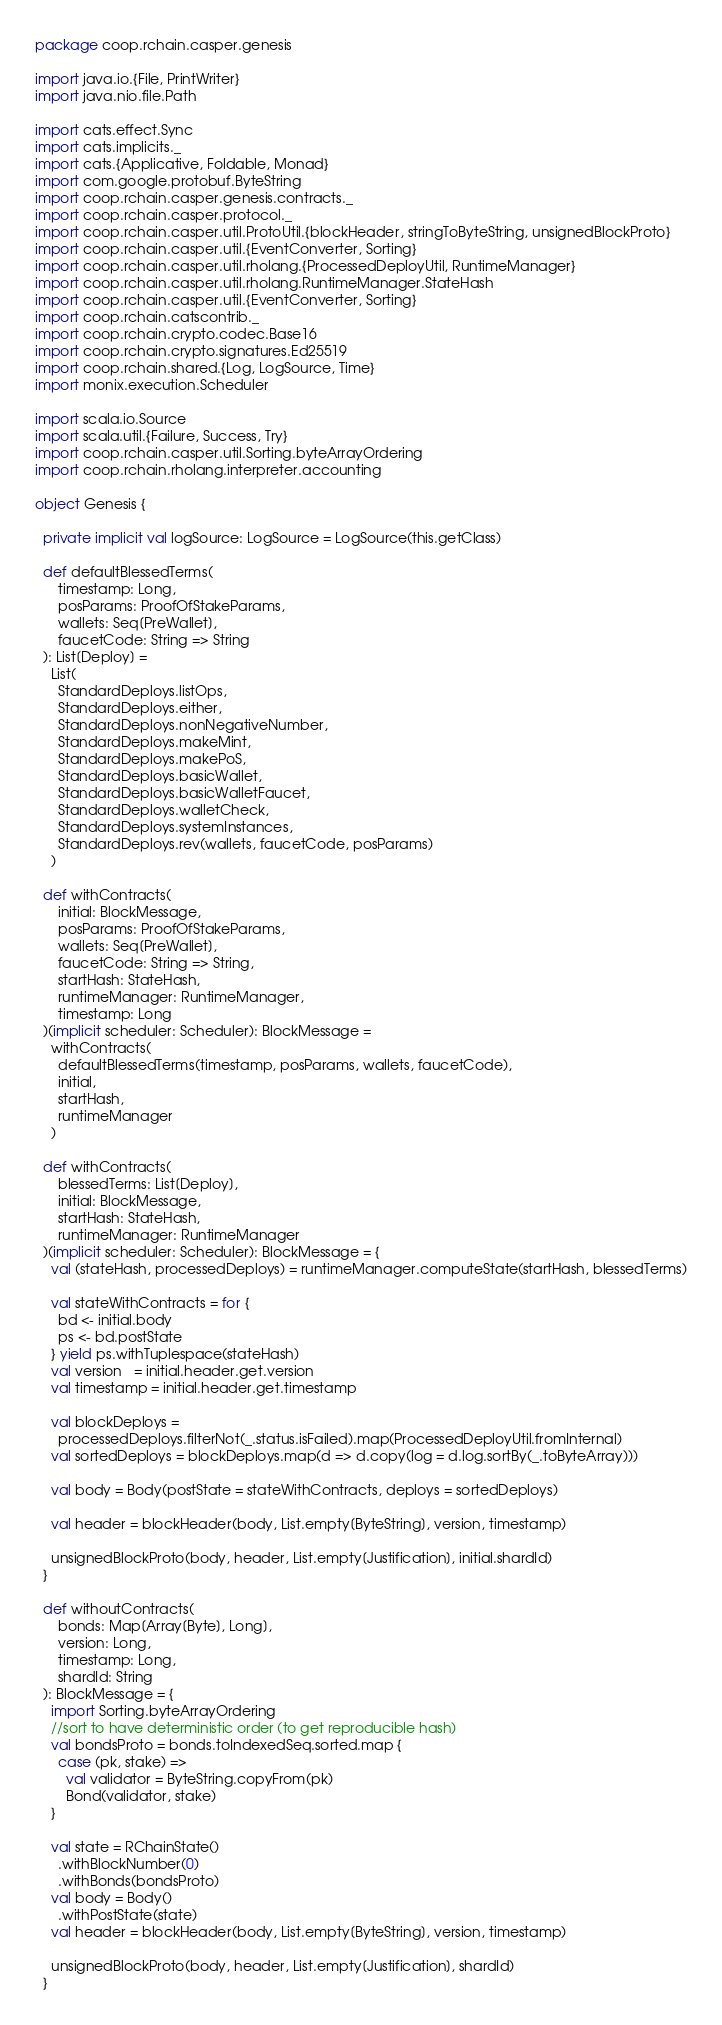<code> <loc_0><loc_0><loc_500><loc_500><_Scala_>package coop.rchain.casper.genesis

import java.io.{File, PrintWriter}
import java.nio.file.Path

import cats.effect.Sync
import cats.implicits._
import cats.{Applicative, Foldable, Monad}
import com.google.protobuf.ByteString
import coop.rchain.casper.genesis.contracts._
import coop.rchain.casper.protocol._
import coop.rchain.casper.util.ProtoUtil.{blockHeader, stringToByteString, unsignedBlockProto}
import coop.rchain.casper.util.{EventConverter, Sorting}
import coop.rchain.casper.util.rholang.{ProcessedDeployUtil, RuntimeManager}
import coop.rchain.casper.util.rholang.RuntimeManager.StateHash
import coop.rchain.casper.util.{EventConverter, Sorting}
import coop.rchain.catscontrib._
import coop.rchain.crypto.codec.Base16
import coop.rchain.crypto.signatures.Ed25519
import coop.rchain.shared.{Log, LogSource, Time}
import monix.execution.Scheduler

import scala.io.Source
import scala.util.{Failure, Success, Try}
import coop.rchain.casper.util.Sorting.byteArrayOrdering
import coop.rchain.rholang.interpreter.accounting

object Genesis {

  private implicit val logSource: LogSource = LogSource(this.getClass)

  def defaultBlessedTerms(
      timestamp: Long,
      posParams: ProofOfStakeParams,
      wallets: Seq[PreWallet],
      faucetCode: String => String
  ): List[Deploy] =
    List(
      StandardDeploys.listOps,
      StandardDeploys.either,
      StandardDeploys.nonNegativeNumber,
      StandardDeploys.makeMint,
      StandardDeploys.makePoS,
      StandardDeploys.basicWallet,
      StandardDeploys.basicWalletFaucet,
      StandardDeploys.walletCheck,
      StandardDeploys.systemInstances,
      StandardDeploys.rev(wallets, faucetCode, posParams)
    )

  def withContracts(
      initial: BlockMessage,
      posParams: ProofOfStakeParams,
      wallets: Seq[PreWallet],
      faucetCode: String => String,
      startHash: StateHash,
      runtimeManager: RuntimeManager,
      timestamp: Long
  )(implicit scheduler: Scheduler): BlockMessage =
    withContracts(
      defaultBlessedTerms(timestamp, posParams, wallets, faucetCode),
      initial,
      startHash,
      runtimeManager
    )

  def withContracts(
      blessedTerms: List[Deploy],
      initial: BlockMessage,
      startHash: StateHash,
      runtimeManager: RuntimeManager
  )(implicit scheduler: Scheduler): BlockMessage = {
    val (stateHash, processedDeploys) = runtimeManager.computeState(startHash, blessedTerms)

    val stateWithContracts = for {
      bd <- initial.body
      ps <- bd.postState
    } yield ps.withTuplespace(stateHash)
    val version   = initial.header.get.version
    val timestamp = initial.header.get.timestamp

    val blockDeploys =
      processedDeploys.filterNot(_.status.isFailed).map(ProcessedDeployUtil.fromInternal)
    val sortedDeploys = blockDeploys.map(d => d.copy(log = d.log.sortBy(_.toByteArray)))

    val body = Body(postState = stateWithContracts, deploys = sortedDeploys)

    val header = blockHeader(body, List.empty[ByteString], version, timestamp)

    unsignedBlockProto(body, header, List.empty[Justification], initial.shardId)
  }

  def withoutContracts(
      bonds: Map[Array[Byte], Long],
      version: Long,
      timestamp: Long,
      shardId: String
  ): BlockMessage = {
    import Sorting.byteArrayOrdering
    //sort to have deterministic order (to get reproducible hash)
    val bondsProto = bonds.toIndexedSeq.sorted.map {
      case (pk, stake) =>
        val validator = ByteString.copyFrom(pk)
        Bond(validator, stake)
    }

    val state = RChainState()
      .withBlockNumber(0)
      .withBonds(bondsProto)
    val body = Body()
      .withPostState(state)
    val header = blockHeader(body, List.empty[ByteString], version, timestamp)

    unsignedBlockProto(body, header, List.empty[Justification], shardId)
  }
</code> 